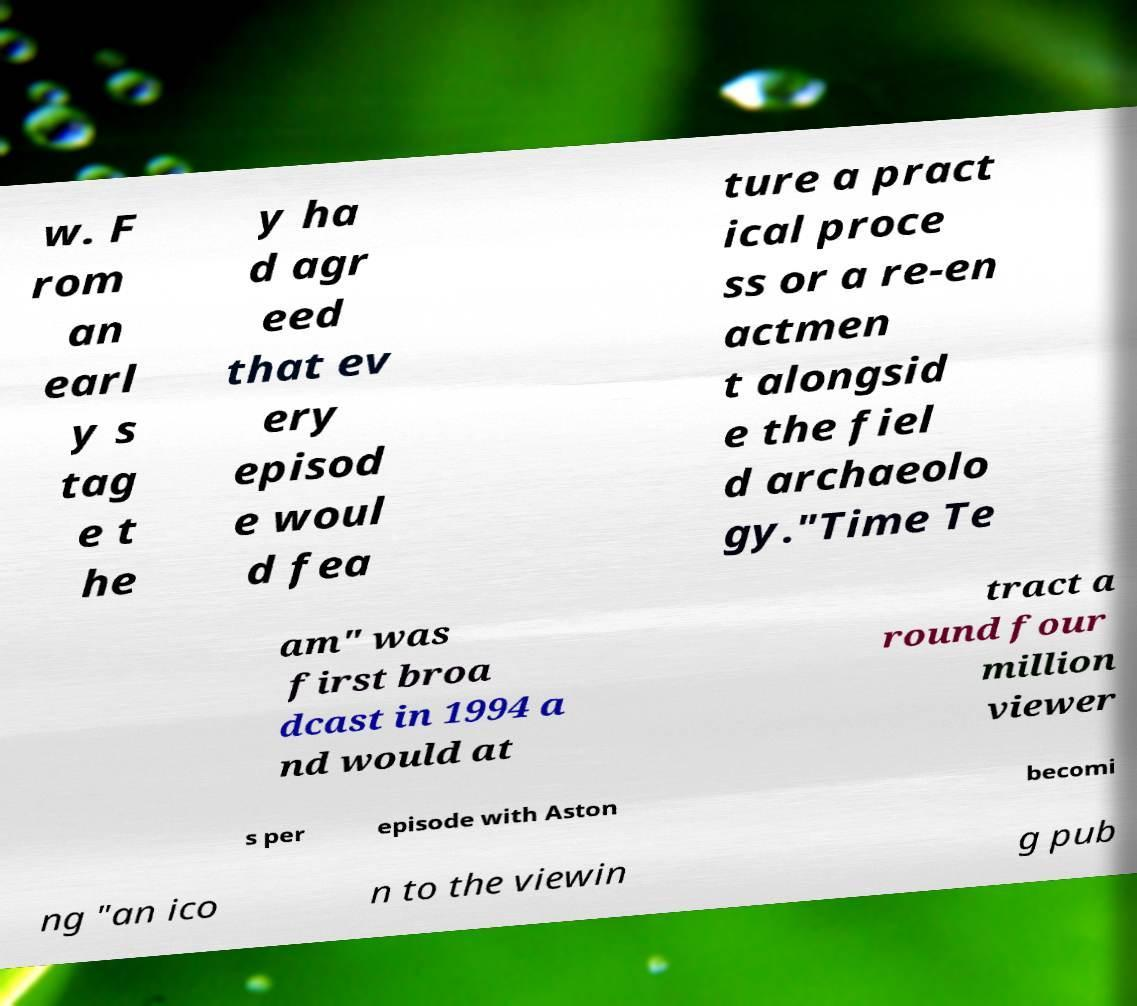For documentation purposes, I need the text within this image transcribed. Could you provide that? w. F rom an earl y s tag e t he y ha d agr eed that ev ery episod e woul d fea ture a pract ical proce ss or a re-en actmen t alongsid e the fiel d archaeolo gy."Time Te am" was first broa dcast in 1994 a nd would at tract a round four million viewer s per episode with Aston becomi ng "an ico n to the viewin g pub 